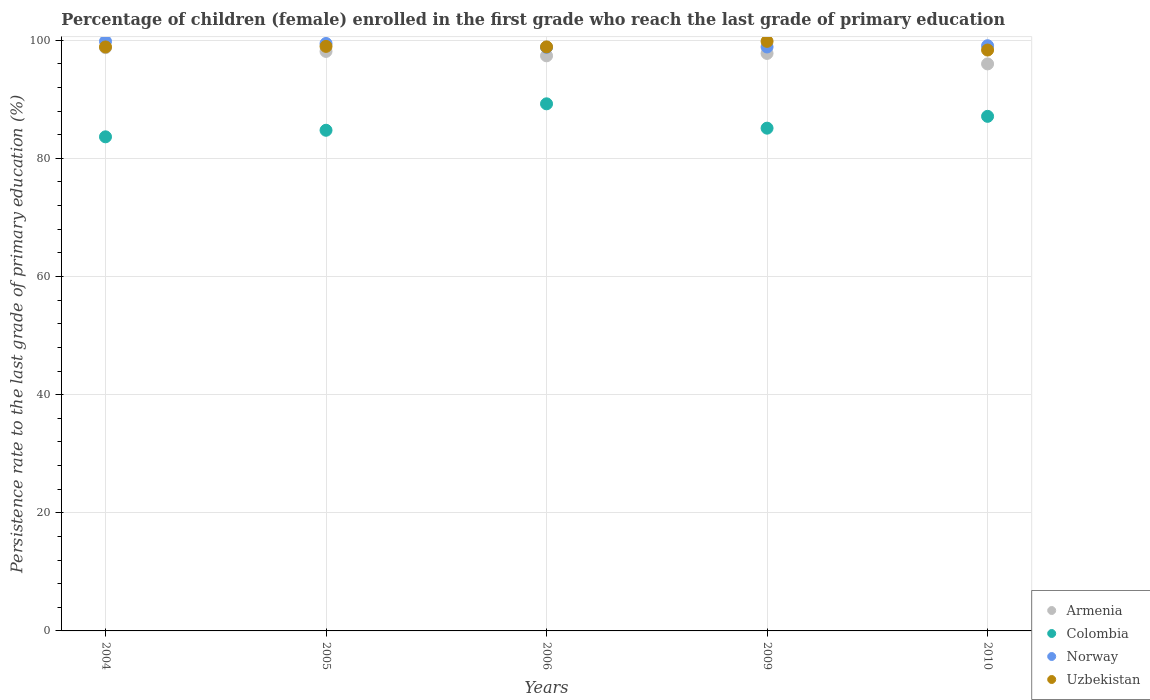How many different coloured dotlines are there?
Give a very brief answer. 4. What is the persistence rate of children in Uzbekistan in 2004?
Provide a short and direct response. 98.86. Across all years, what is the maximum persistence rate of children in Uzbekistan?
Give a very brief answer. 99.81. Across all years, what is the minimum persistence rate of children in Colombia?
Your response must be concise. 83.64. What is the total persistence rate of children in Uzbekistan in the graph?
Make the answer very short. 494.83. What is the difference between the persistence rate of children in Armenia in 2004 and that in 2009?
Give a very brief answer. 0.97. What is the difference between the persistence rate of children in Uzbekistan in 2009 and the persistence rate of children in Colombia in 2010?
Give a very brief answer. 12.69. What is the average persistence rate of children in Norway per year?
Make the answer very short. 99.19. In the year 2004, what is the difference between the persistence rate of children in Armenia and persistence rate of children in Colombia?
Give a very brief answer. 15.09. What is the ratio of the persistence rate of children in Colombia in 2005 to that in 2009?
Your response must be concise. 1. Is the persistence rate of children in Colombia in 2004 less than that in 2005?
Give a very brief answer. Yes. Is the difference between the persistence rate of children in Armenia in 2004 and 2010 greater than the difference between the persistence rate of children in Colombia in 2004 and 2010?
Keep it short and to the point. Yes. What is the difference between the highest and the second highest persistence rate of children in Norway?
Your answer should be compact. 0.36. What is the difference between the highest and the lowest persistence rate of children in Armenia?
Offer a very short reply. 2.75. Does the persistence rate of children in Uzbekistan monotonically increase over the years?
Offer a terse response. No. Is the persistence rate of children in Norway strictly less than the persistence rate of children in Armenia over the years?
Provide a succinct answer. No. Does the graph contain grids?
Keep it short and to the point. Yes. Where does the legend appear in the graph?
Your answer should be compact. Bottom right. How many legend labels are there?
Offer a terse response. 4. What is the title of the graph?
Provide a short and direct response. Percentage of children (female) enrolled in the first grade who reach the last grade of primary education. What is the label or title of the X-axis?
Ensure brevity in your answer.  Years. What is the label or title of the Y-axis?
Offer a terse response. Persistence rate to the last grade of primary education (%). What is the Persistence rate to the last grade of primary education (%) in Armenia in 2004?
Keep it short and to the point. 98.74. What is the Persistence rate to the last grade of primary education (%) in Colombia in 2004?
Provide a short and direct response. 83.64. What is the Persistence rate to the last grade of primary education (%) of Norway in 2004?
Offer a very short reply. 99.8. What is the Persistence rate to the last grade of primary education (%) of Uzbekistan in 2004?
Offer a very short reply. 98.86. What is the Persistence rate to the last grade of primary education (%) of Armenia in 2005?
Keep it short and to the point. 98.1. What is the Persistence rate to the last grade of primary education (%) of Colombia in 2005?
Provide a succinct answer. 84.75. What is the Persistence rate to the last grade of primary education (%) of Norway in 2005?
Make the answer very short. 99.45. What is the Persistence rate to the last grade of primary education (%) in Uzbekistan in 2005?
Provide a short and direct response. 98.95. What is the Persistence rate to the last grade of primary education (%) in Armenia in 2006?
Give a very brief answer. 97.36. What is the Persistence rate to the last grade of primary education (%) in Colombia in 2006?
Ensure brevity in your answer.  89.23. What is the Persistence rate to the last grade of primary education (%) in Norway in 2006?
Provide a short and direct response. 98.8. What is the Persistence rate to the last grade of primary education (%) in Uzbekistan in 2006?
Offer a terse response. 98.87. What is the Persistence rate to the last grade of primary education (%) in Armenia in 2009?
Provide a short and direct response. 97.76. What is the Persistence rate to the last grade of primary education (%) of Colombia in 2009?
Give a very brief answer. 85.11. What is the Persistence rate to the last grade of primary education (%) in Norway in 2009?
Provide a succinct answer. 98.85. What is the Persistence rate to the last grade of primary education (%) in Uzbekistan in 2009?
Ensure brevity in your answer.  99.81. What is the Persistence rate to the last grade of primary education (%) in Armenia in 2010?
Provide a short and direct response. 95.99. What is the Persistence rate to the last grade of primary education (%) in Colombia in 2010?
Provide a short and direct response. 87.11. What is the Persistence rate to the last grade of primary education (%) of Norway in 2010?
Offer a terse response. 99.07. What is the Persistence rate to the last grade of primary education (%) of Uzbekistan in 2010?
Your answer should be very brief. 98.33. Across all years, what is the maximum Persistence rate to the last grade of primary education (%) of Armenia?
Your answer should be compact. 98.74. Across all years, what is the maximum Persistence rate to the last grade of primary education (%) in Colombia?
Make the answer very short. 89.23. Across all years, what is the maximum Persistence rate to the last grade of primary education (%) of Norway?
Offer a very short reply. 99.8. Across all years, what is the maximum Persistence rate to the last grade of primary education (%) in Uzbekistan?
Offer a very short reply. 99.81. Across all years, what is the minimum Persistence rate to the last grade of primary education (%) of Armenia?
Ensure brevity in your answer.  95.99. Across all years, what is the minimum Persistence rate to the last grade of primary education (%) of Colombia?
Give a very brief answer. 83.64. Across all years, what is the minimum Persistence rate to the last grade of primary education (%) in Norway?
Provide a short and direct response. 98.8. Across all years, what is the minimum Persistence rate to the last grade of primary education (%) in Uzbekistan?
Provide a short and direct response. 98.33. What is the total Persistence rate to the last grade of primary education (%) in Armenia in the graph?
Make the answer very short. 487.95. What is the total Persistence rate to the last grade of primary education (%) of Colombia in the graph?
Give a very brief answer. 429.85. What is the total Persistence rate to the last grade of primary education (%) of Norway in the graph?
Provide a short and direct response. 495.97. What is the total Persistence rate to the last grade of primary education (%) in Uzbekistan in the graph?
Offer a terse response. 494.83. What is the difference between the Persistence rate to the last grade of primary education (%) in Armenia in 2004 and that in 2005?
Provide a succinct answer. 0.63. What is the difference between the Persistence rate to the last grade of primary education (%) in Colombia in 2004 and that in 2005?
Provide a succinct answer. -1.11. What is the difference between the Persistence rate to the last grade of primary education (%) in Norway in 2004 and that in 2005?
Offer a very short reply. 0.36. What is the difference between the Persistence rate to the last grade of primary education (%) of Uzbekistan in 2004 and that in 2005?
Your response must be concise. -0.09. What is the difference between the Persistence rate to the last grade of primary education (%) of Armenia in 2004 and that in 2006?
Make the answer very short. 1.38. What is the difference between the Persistence rate to the last grade of primary education (%) of Colombia in 2004 and that in 2006?
Make the answer very short. -5.59. What is the difference between the Persistence rate to the last grade of primary education (%) in Norway in 2004 and that in 2006?
Provide a short and direct response. 1.01. What is the difference between the Persistence rate to the last grade of primary education (%) in Uzbekistan in 2004 and that in 2006?
Keep it short and to the point. -0.01. What is the difference between the Persistence rate to the last grade of primary education (%) in Armenia in 2004 and that in 2009?
Your response must be concise. 0.97. What is the difference between the Persistence rate to the last grade of primary education (%) in Colombia in 2004 and that in 2009?
Offer a very short reply. -1.47. What is the difference between the Persistence rate to the last grade of primary education (%) of Norway in 2004 and that in 2009?
Your answer should be compact. 0.95. What is the difference between the Persistence rate to the last grade of primary education (%) in Uzbekistan in 2004 and that in 2009?
Make the answer very short. -0.95. What is the difference between the Persistence rate to the last grade of primary education (%) in Armenia in 2004 and that in 2010?
Keep it short and to the point. 2.75. What is the difference between the Persistence rate to the last grade of primary education (%) of Colombia in 2004 and that in 2010?
Make the answer very short. -3.47. What is the difference between the Persistence rate to the last grade of primary education (%) in Norway in 2004 and that in 2010?
Offer a terse response. 0.74. What is the difference between the Persistence rate to the last grade of primary education (%) of Uzbekistan in 2004 and that in 2010?
Your response must be concise. 0.53. What is the difference between the Persistence rate to the last grade of primary education (%) of Armenia in 2005 and that in 2006?
Your answer should be compact. 0.75. What is the difference between the Persistence rate to the last grade of primary education (%) of Colombia in 2005 and that in 2006?
Give a very brief answer. -4.48. What is the difference between the Persistence rate to the last grade of primary education (%) in Norway in 2005 and that in 2006?
Offer a terse response. 0.65. What is the difference between the Persistence rate to the last grade of primary education (%) in Uzbekistan in 2005 and that in 2006?
Provide a succinct answer. 0.08. What is the difference between the Persistence rate to the last grade of primary education (%) in Armenia in 2005 and that in 2009?
Ensure brevity in your answer.  0.34. What is the difference between the Persistence rate to the last grade of primary education (%) of Colombia in 2005 and that in 2009?
Your response must be concise. -0.36. What is the difference between the Persistence rate to the last grade of primary education (%) of Norway in 2005 and that in 2009?
Offer a terse response. 0.59. What is the difference between the Persistence rate to the last grade of primary education (%) of Uzbekistan in 2005 and that in 2009?
Offer a very short reply. -0.85. What is the difference between the Persistence rate to the last grade of primary education (%) of Armenia in 2005 and that in 2010?
Your answer should be compact. 2.12. What is the difference between the Persistence rate to the last grade of primary education (%) in Colombia in 2005 and that in 2010?
Your answer should be compact. -2.36. What is the difference between the Persistence rate to the last grade of primary education (%) in Norway in 2005 and that in 2010?
Offer a very short reply. 0.38. What is the difference between the Persistence rate to the last grade of primary education (%) in Uzbekistan in 2005 and that in 2010?
Offer a very short reply. 0.62. What is the difference between the Persistence rate to the last grade of primary education (%) in Armenia in 2006 and that in 2009?
Your response must be concise. -0.41. What is the difference between the Persistence rate to the last grade of primary education (%) of Colombia in 2006 and that in 2009?
Make the answer very short. 4.12. What is the difference between the Persistence rate to the last grade of primary education (%) in Norway in 2006 and that in 2009?
Provide a succinct answer. -0.06. What is the difference between the Persistence rate to the last grade of primary education (%) of Uzbekistan in 2006 and that in 2009?
Give a very brief answer. -0.94. What is the difference between the Persistence rate to the last grade of primary education (%) of Armenia in 2006 and that in 2010?
Your answer should be compact. 1.37. What is the difference between the Persistence rate to the last grade of primary education (%) in Colombia in 2006 and that in 2010?
Offer a terse response. 2.12. What is the difference between the Persistence rate to the last grade of primary education (%) of Norway in 2006 and that in 2010?
Ensure brevity in your answer.  -0.27. What is the difference between the Persistence rate to the last grade of primary education (%) in Uzbekistan in 2006 and that in 2010?
Provide a succinct answer. 0.54. What is the difference between the Persistence rate to the last grade of primary education (%) of Armenia in 2009 and that in 2010?
Your answer should be very brief. 1.77. What is the difference between the Persistence rate to the last grade of primary education (%) of Colombia in 2009 and that in 2010?
Your answer should be very brief. -2. What is the difference between the Persistence rate to the last grade of primary education (%) in Norway in 2009 and that in 2010?
Provide a succinct answer. -0.21. What is the difference between the Persistence rate to the last grade of primary education (%) of Uzbekistan in 2009 and that in 2010?
Keep it short and to the point. 1.47. What is the difference between the Persistence rate to the last grade of primary education (%) of Armenia in 2004 and the Persistence rate to the last grade of primary education (%) of Colombia in 2005?
Offer a very short reply. 13.98. What is the difference between the Persistence rate to the last grade of primary education (%) of Armenia in 2004 and the Persistence rate to the last grade of primary education (%) of Norway in 2005?
Your answer should be very brief. -0.71. What is the difference between the Persistence rate to the last grade of primary education (%) of Armenia in 2004 and the Persistence rate to the last grade of primary education (%) of Uzbekistan in 2005?
Offer a very short reply. -0.22. What is the difference between the Persistence rate to the last grade of primary education (%) in Colombia in 2004 and the Persistence rate to the last grade of primary education (%) in Norway in 2005?
Give a very brief answer. -15.8. What is the difference between the Persistence rate to the last grade of primary education (%) of Colombia in 2004 and the Persistence rate to the last grade of primary education (%) of Uzbekistan in 2005?
Provide a succinct answer. -15.31. What is the difference between the Persistence rate to the last grade of primary education (%) in Norway in 2004 and the Persistence rate to the last grade of primary education (%) in Uzbekistan in 2005?
Your response must be concise. 0.85. What is the difference between the Persistence rate to the last grade of primary education (%) in Armenia in 2004 and the Persistence rate to the last grade of primary education (%) in Colombia in 2006?
Provide a short and direct response. 9.51. What is the difference between the Persistence rate to the last grade of primary education (%) in Armenia in 2004 and the Persistence rate to the last grade of primary education (%) in Norway in 2006?
Your answer should be compact. -0.06. What is the difference between the Persistence rate to the last grade of primary education (%) of Armenia in 2004 and the Persistence rate to the last grade of primary education (%) of Uzbekistan in 2006?
Your response must be concise. -0.13. What is the difference between the Persistence rate to the last grade of primary education (%) in Colombia in 2004 and the Persistence rate to the last grade of primary education (%) in Norway in 2006?
Provide a short and direct response. -15.15. What is the difference between the Persistence rate to the last grade of primary education (%) of Colombia in 2004 and the Persistence rate to the last grade of primary education (%) of Uzbekistan in 2006?
Offer a very short reply. -15.23. What is the difference between the Persistence rate to the last grade of primary education (%) in Norway in 2004 and the Persistence rate to the last grade of primary education (%) in Uzbekistan in 2006?
Your answer should be compact. 0.93. What is the difference between the Persistence rate to the last grade of primary education (%) in Armenia in 2004 and the Persistence rate to the last grade of primary education (%) in Colombia in 2009?
Provide a short and direct response. 13.63. What is the difference between the Persistence rate to the last grade of primary education (%) in Armenia in 2004 and the Persistence rate to the last grade of primary education (%) in Norway in 2009?
Keep it short and to the point. -0.12. What is the difference between the Persistence rate to the last grade of primary education (%) in Armenia in 2004 and the Persistence rate to the last grade of primary education (%) in Uzbekistan in 2009?
Offer a terse response. -1.07. What is the difference between the Persistence rate to the last grade of primary education (%) in Colombia in 2004 and the Persistence rate to the last grade of primary education (%) in Norway in 2009?
Ensure brevity in your answer.  -15.21. What is the difference between the Persistence rate to the last grade of primary education (%) in Colombia in 2004 and the Persistence rate to the last grade of primary education (%) in Uzbekistan in 2009?
Ensure brevity in your answer.  -16.16. What is the difference between the Persistence rate to the last grade of primary education (%) of Norway in 2004 and the Persistence rate to the last grade of primary education (%) of Uzbekistan in 2009?
Offer a very short reply. -0. What is the difference between the Persistence rate to the last grade of primary education (%) in Armenia in 2004 and the Persistence rate to the last grade of primary education (%) in Colombia in 2010?
Your response must be concise. 11.62. What is the difference between the Persistence rate to the last grade of primary education (%) of Armenia in 2004 and the Persistence rate to the last grade of primary education (%) of Norway in 2010?
Offer a very short reply. -0.33. What is the difference between the Persistence rate to the last grade of primary education (%) in Armenia in 2004 and the Persistence rate to the last grade of primary education (%) in Uzbekistan in 2010?
Give a very brief answer. 0.4. What is the difference between the Persistence rate to the last grade of primary education (%) in Colombia in 2004 and the Persistence rate to the last grade of primary education (%) in Norway in 2010?
Your response must be concise. -15.42. What is the difference between the Persistence rate to the last grade of primary education (%) in Colombia in 2004 and the Persistence rate to the last grade of primary education (%) in Uzbekistan in 2010?
Offer a very short reply. -14.69. What is the difference between the Persistence rate to the last grade of primary education (%) of Norway in 2004 and the Persistence rate to the last grade of primary education (%) of Uzbekistan in 2010?
Make the answer very short. 1.47. What is the difference between the Persistence rate to the last grade of primary education (%) of Armenia in 2005 and the Persistence rate to the last grade of primary education (%) of Colombia in 2006?
Give a very brief answer. 8.87. What is the difference between the Persistence rate to the last grade of primary education (%) of Armenia in 2005 and the Persistence rate to the last grade of primary education (%) of Norway in 2006?
Ensure brevity in your answer.  -0.69. What is the difference between the Persistence rate to the last grade of primary education (%) in Armenia in 2005 and the Persistence rate to the last grade of primary education (%) in Uzbekistan in 2006?
Your answer should be very brief. -0.77. What is the difference between the Persistence rate to the last grade of primary education (%) in Colombia in 2005 and the Persistence rate to the last grade of primary education (%) in Norway in 2006?
Make the answer very short. -14.04. What is the difference between the Persistence rate to the last grade of primary education (%) of Colombia in 2005 and the Persistence rate to the last grade of primary education (%) of Uzbekistan in 2006?
Give a very brief answer. -14.12. What is the difference between the Persistence rate to the last grade of primary education (%) in Norway in 2005 and the Persistence rate to the last grade of primary education (%) in Uzbekistan in 2006?
Your answer should be compact. 0.58. What is the difference between the Persistence rate to the last grade of primary education (%) in Armenia in 2005 and the Persistence rate to the last grade of primary education (%) in Colombia in 2009?
Give a very brief answer. 12.99. What is the difference between the Persistence rate to the last grade of primary education (%) in Armenia in 2005 and the Persistence rate to the last grade of primary education (%) in Norway in 2009?
Your answer should be very brief. -0.75. What is the difference between the Persistence rate to the last grade of primary education (%) in Armenia in 2005 and the Persistence rate to the last grade of primary education (%) in Uzbekistan in 2009?
Your answer should be very brief. -1.7. What is the difference between the Persistence rate to the last grade of primary education (%) of Colombia in 2005 and the Persistence rate to the last grade of primary education (%) of Norway in 2009?
Ensure brevity in your answer.  -14.1. What is the difference between the Persistence rate to the last grade of primary education (%) of Colombia in 2005 and the Persistence rate to the last grade of primary education (%) of Uzbekistan in 2009?
Offer a very short reply. -15.05. What is the difference between the Persistence rate to the last grade of primary education (%) of Norway in 2005 and the Persistence rate to the last grade of primary education (%) of Uzbekistan in 2009?
Ensure brevity in your answer.  -0.36. What is the difference between the Persistence rate to the last grade of primary education (%) of Armenia in 2005 and the Persistence rate to the last grade of primary education (%) of Colombia in 2010?
Provide a succinct answer. 10.99. What is the difference between the Persistence rate to the last grade of primary education (%) of Armenia in 2005 and the Persistence rate to the last grade of primary education (%) of Norway in 2010?
Keep it short and to the point. -0.96. What is the difference between the Persistence rate to the last grade of primary education (%) in Armenia in 2005 and the Persistence rate to the last grade of primary education (%) in Uzbekistan in 2010?
Your response must be concise. -0.23. What is the difference between the Persistence rate to the last grade of primary education (%) of Colombia in 2005 and the Persistence rate to the last grade of primary education (%) of Norway in 2010?
Your answer should be compact. -14.31. What is the difference between the Persistence rate to the last grade of primary education (%) in Colombia in 2005 and the Persistence rate to the last grade of primary education (%) in Uzbekistan in 2010?
Offer a very short reply. -13.58. What is the difference between the Persistence rate to the last grade of primary education (%) in Norway in 2005 and the Persistence rate to the last grade of primary education (%) in Uzbekistan in 2010?
Ensure brevity in your answer.  1.11. What is the difference between the Persistence rate to the last grade of primary education (%) in Armenia in 2006 and the Persistence rate to the last grade of primary education (%) in Colombia in 2009?
Your answer should be compact. 12.25. What is the difference between the Persistence rate to the last grade of primary education (%) of Armenia in 2006 and the Persistence rate to the last grade of primary education (%) of Norway in 2009?
Your answer should be compact. -1.5. What is the difference between the Persistence rate to the last grade of primary education (%) of Armenia in 2006 and the Persistence rate to the last grade of primary education (%) of Uzbekistan in 2009?
Provide a short and direct response. -2.45. What is the difference between the Persistence rate to the last grade of primary education (%) in Colombia in 2006 and the Persistence rate to the last grade of primary education (%) in Norway in 2009?
Offer a terse response. -9.62. What is the difference between the Persistence rate to the last grade of primary education (%) of Colombia in 2006 and the Persistence rate to the last grade of primary education (%) of Uzbekistan in 2009?
Provide a succinct answer. -10.58. What is the difference between the Persistence rate to the last grade of primary education (%) of Norway in 2006 and the Persistence rate to the last grade of primary education (%) of Uzbekistan in 2009?
Your answer should be compact. -1.01. What is the difference between the Persistence rate to the last grade of primary education (%) in Armenia in 2006 and the Persistence rate to the last grade of primary education (%) in Colombia in 2010?
Your answer should be compact. 10.24. What is the difference between the Persistence rate to the last grade of primary education (%) of Armenia in 2006 and the Persistence rate to the last grade of primary education (%) of Norway in 2010?
Your answer should be compact. -1.71. What is the difference between the Persistence rate to the last grade of primary education (%) of Armenia in 2006 and the Persistence rate to the last grade of primary education (%) of Uzbekistan in 2010?
Offer a very short reply. -0.98. What is the difference between the Persistence rate to the last grade of primary education (%) of Colombia in 2006 and the Persistence rate to the last grade of primary education (%) of Norway in 2010?
Provide a short and direct response. -9.84. What is the difference between the Persistence rate to the last grade of primary education (%) in Colombia in 2006 and the Persistence rate to the last grade of primary education (%) in Uzbekistan in 2010?
Your answer should be compact. -9.1. What is the difference between the Persistence rate to the last grade of primary education (%) in Norway in 2006 and the Persistence rate to the last grade of primary education (%) in Uzbekistan in 2010?
Offer a very short reply. 0.46. What is the difference between the Persistence rate to the last grade of primary education (%) of Armenia in 2009 and the Persistence rate to the last grade of primary education (%) of Colombia in 2010?
Give a very brief answer. 10.65. What is the difference between the Persistence rate to the last grade of primary education (%) in Armenia in 2009 and the Persistence rate to the last grade of primary education (%) in Norway in 2010?
Provide a short and direct response. -1.3. What is the difference between the Persistence rate to the last grade of primary education (%) of Armenia in 2009 and the Persistence rate to the last grade of primary education (%) of Uzbekistan in 2010?
Your answer should be very brief. -0.57. What is the difference between the Persistence rate to the last grade of primary education (%) of Colombia in 2009 and the Persistence rate to the last grade of primary education (%) of Norway in 2010?
Make the answer very short. -13.96. What is the difference between the Persistence rate to the last grade of primary education (%) of Colombia in 2009 and the Persistence rate to the last grade of primary education (%) of Uzbekistan in 2010?
Offer a very short reply. -13.22. What is the difference between the Persistence rate to the last grade of primary education (%) of Norway in 2009 and the Persistence rate to the last grade of primary education (%) of Uzbekistan in 2010?
Ensure brevity in your answer.  0.52. What is the average Persistence rate to the last grade of primary education (%) in Armenia per year?
Your response must be concise. 97.59. What is the average Persistence rate to the last grade of primary education (%) of Colombia per year?
Keep it short and to the point. 85.97. What is the average Persistence rate to the last grade of primary education (%) in Norway per year?
Offer a very short reply. 99.19. What is the average Persistence rate to the last grade of primary education (%) of Uzbekistan per year?
Make the answer very short. 98.97. In the year 2004, what is the difference between the Persistence rate to the last grade of primary education (%) in Armenia and Persistence rate to the last grade of primary education (%) in Colombia?
Your answer should be very brief. 15.09. In the year 2004, what is the difference between the Persistence rate to the last grade of primary education (%) of Armenia and Persistence rate to the last grade of primary education (%) of Norway?
Offer a very short reply. -1.07. In the year 2004, what is the difference between the Persistence rate to the last grade of primary education (%) of Armenia and Persistence rate to the last grade of primary education (%) of Uzbekistan?
Give a very brief answer. -0.12. In the year 2004, what is the difference between the Persistence rate to the last grade of primary education (%) of Colombia and Persistence rate to the last grade of primary education (%) of Norway?
Make the answer very short. -16.16. In the year 2004, what is the difference between the Persistence rate to the last grade of primary education (%) in Colombia and Persistence rate to the last grade of primary education (%) in Uzbekistan?
Offer a terse response. -15.22. In the year 2004, what is the difference between the Persistence rate to the last grade of primary education (%) in Norway and Persistence rate to the last grade of primary education (%) in Uzbekistan?
Your answer should be compact. 0.94. In the year 2005, what is the difference between the Persistence rate to the last grade of primary education (%) in Armenia and Persistence rate to the last grade of primary education (%) in Colombia?
Offer a terse response. 13.35. In the year 2005, what is the difference between the Persistence rate to the last grade of primary education (%) in Armenia and Persistence rate to the last grade of primary education (%) in Norway?
Provide a short and direct response. -1.34. In the year 2005, what is the difference between the Persistence rate to the last grade of primary education (%) of Armenia and Persistence rate to the last grade of primary education (%) of Uzbekistan?
Provide a short and direct response. -0.85. In the year 2005, what is the difference between the Persistence rate to the last grade of primary education (%) in Colombia and Persistence rate to the last grade of primary education (%) in Norway?
Offer a terse response. -14.69. In the year 2005, what is the difference between the Persistence rate to the last grade of primary education (%) of Colombia and Persistence rate to the last grade of primary education (%) of Uzbekistan?
Provide a succinct answer. -14.2. In the year 2005, what is the difference between the Persistence rate to the last grade of primary education (%) in Norway and Persistence rate to the last grade of primary education (%) in Uzbekistan?
Your answer should be compact. 0.49. In the year 2006, what is the difference between the Persistence rate to the last grade of primary education (%) of Armenia and Persistence rate to the last grade of primary education (%) of Colombia?
Your response must be concise. 8.13. In the year 2006, what is the difference between the Persistence rate to the last grade of primary education (%) in Armenia and Persistence rate to the last grade of primary education (%) in Norway?
Your response must be concise. -1.44. In the year 2006, what is the difference between the Persistence rate to the last grade of primary education (%) in Armenia and Persistence rate to the last grade of primary education (%) in Uzbekistan?
Make the answer very short. -1.51. In the year 2006, what is the difference between the Persistence rate to the last grade of primary education (%) of Colombia and Persistence rate to the last grade of primary education (%) of Norway?
Keep it short and to the point. -9.56. In the year 2006, what is the difference between the Persistence rate to the last grade of primary education (%) of Colombia and Persistence rate to the last grade of primary education (%) of Uzbekistan?
Give a very brief answer. -9.64. In the year 2006, what is the difference between the Persistence rate to the last grade of primary education (%) in Norway and Persistence rate to the last grade of primary education (%) in Uzbekistan?
Ensure brevity in your answer.  -0.08. In the year 2009, what is the difference between the Persistence rate to the last grade of primary education (%) of Armenia and Persistence rate to the last grade of primary education (%) of Colombia?
Ensure brevity in your answer.  12.65. In the year 2009, what is the difference between the Persistence rate to the last grade of primary education (%) of Armenia and Persistence rate to the last grade of primary education (%) of Norway?
Make the answer very short. -1.09. In the year 2009, what is the difference between the Persistence rate to the last grade of primary education (%) of Armenia and Persistence rate to the last grade of primary education (%) of Uzbekistan?
Your response must be concise. -2.04. In the year 2009, what is the difference between the Persistence rate to the last grade of primary education (%) in Colombia and Persistence rate to the last grade of primary education (%) in Norway?
Keep it short and to the point. -13.74. In the year 2009, what is the difference between the Persistence rate to the last grade of primary education (%) in Colombia and Persistence rate to the last grade of primary education (%) in Uzbekistan?
Your answer should be very brief. -14.7. In the year 2009, what is the difference between the Persistence rate to the last grade of primary education (%) of Norway and Persistence rate to the last grade of primary education (%) of Uzbekistan?
Offer a very short reply. -0.95. In the year 2010, what is the difference between the Persistence rate to the last grade of primary education (%) of Armenia and Persistence rate to the last grade of primary education (%) of Colombia?
Provide a short and direct response. 8.88. In the year 2010, what is the difference between the Persistence rate to the last grade of primary education (%) in Armenia and Persistence rate to the last grade of primary education (%) in Norway?
Offer a very short reply. -3.08. In the year 2010, what is the difference between the Persistence rate to the last grade of primary education (%) of Armenia and Persistence rate to the last grade of primary education (%) of Uzbekistan?
Make the answer very short. -2.35. In the year 2010, what is the difference between the Persistence rate to the last grade of primary education (%) of Colombia and Persistence rate to the last grade of primary education (%) of Norway?
Provide a short and direct response. -11.95. In the year 2010, what is the difference between the Persistence rate to the last grade of primary education (%) in Colombia and Persistence rate to the last grade of primary education (%) in Uzbekistan?
Your response must be concise. -11.22. In the year 2010, what is the difference between the Persistence rate to the last grade of primary education (%) of Norway and Persistence rate to the last grade of primary education (%) of Uzbekistan?
Make the answer very short. 0.73. What is the ratio of the Persistence rate to the last grade of primary education (%) of Armenia in 2004 to that in 2005?
Your answer should be compact. 1.01. What is the ratio of the Persistence rate to the last grade of primary education (%) of Colombia in 2004 to that in 2005?
Give a very brief answer. 0.99. What is the ratio of the Persistence rate to the last grade of primary education (%) of Norway in 2004 to that in 2005?
Your answer should be compact. 1. What is the ratio of the Persistence rate to the last grade of primary education (%) in Armenia in 2004 to that in 2006?
Ensure brevity in your answer.  1.01. What is the ratio of the Persistence rate to the last grade of primary education (%) in Colombia in 2004 to that in 2006?
Give a very brief answer. 0.94. What is the ratio of the Persistence rate to the last grade of primary education (%) in Norway in 2004 to that in 2006?
Provide a short and direct response. 1.01. What is the ratio of the Persistence rate to the last grade of primary education (%) of Armenia in 2004 to that in 2009?
Offer a very short reply. 1.01. What is the ratio of the Persistence rate to the last grade of primary education (%) in Colombia in 2004 to that in 2009?
Keep it short and to the point. 0.98. What is the ratio of the Persistence rate to the last grade of primary education (%) in Norway in 2004 to that in 2009?
Keep it short and to the point. 1.01. What is the ratio of the Persistence rate to the last grade of primary education (%) of Armenia in 2004 to that in 2010?
Make the answer very short. 1.03. What is the ratio of the Persistence rate to the last grade of primary education (%) in Colombia in 2004 to that in 2010?
Provide a succinct answer. 0.96. What is the ratio of the Persistence rate to the last grade of primary education (%) in Norway in 2004 to that in 2010?
Ensure brevity in your answer.  1.01. What is the ratio of the Persistence rate to the last grade of primary education (%) in Uzbekistan in 2004 to that in 2010?
Provide a short and direct response. 1.01. What is the ratio of the Persistence rate to the last grade of primary education (%) of Armenia in 2005 to that in 2006?
Keep it short and to the point. 1.01. What is the ratio of the Persistence rate to the last grade of primary education (%) in Colombia in 2005 to that in 2006?
Your answer should be compact. 0.95. What is the ratio of the Persistence rate to the last grade of primary education (%) in Norway in 2005 to that in 2006?
Keep it short and to the point. 1.01. What is the ratio of the Persistence rate to the last grade of primary education (%) in Colombia in 2005 to that in 2009?
Your response must be concise. 1. What is the ratio of the Persistence rate to the last grade of primary education (%) of Norway in 2005 to that in 2009?
Give a very brief answer. 1.01. What is the ratio of the Persistence rate to the last grade of primary education (%) of Armenia in 2005 to that in 2010?
Offer a terse response. 1.02. What is the ratio of the Persistence rate to the last grade of primary education (%) of Colombia in 2005 to that in 2010?
Provide a succinct answer. 0.97. What is the ratio of the Persistence rate to the last grade of primary education (%) in Norway in 2005 to that in 2010?
Offer a terse response. 1. What is the ratio of the Persistence rate to the last grade of primary education (%) in Uzbekistan in 2005 to that in 2010?
Ensure brevity in your answer.  1.01. What is the ratio of the Persistence rate to the last grade of primary education (%) in Armenia in 2006 to that in 2009?
Your answer should be compact. 1. What is the ratio of the Persistence rate to the last grade of primary education (%) of Colombia in 2006 to that in 2009?
Your answer should be compact. 1.05. What is the ratio of the Persistence rate to the last grade of primary education (%) of Norway in 2006 to that in 2009?
Ensure brevity in your answer.  1. What is the ratio of the Persistence rate to the last grade of primary education (%) in Uzbekistan in 2006 to that in 2009?
Offer a terse response. 0.99. What is the ratio of the Persistence rate to the last grade of primary education (%) in Armenia in 2006 to that in 2010?
Your response must be concise. 1.01. What is the ratio of the Persistence rate to the last grade of primary education (%) in Colombia in 2006 to that in 2010?
Your answer should be very brief. 1.02. What is the ratio of the Persistence rate to the last grade of primary education (%) of Norway in 2006 to that in 2010?
Provide a succinct answer. 1. What is the ratio of the Persistence rate to the last grade of primary education (%) of Armenia in 2009 to that in 2010?
Your response must be concise. 1.02. What is the ratio of the Persistence rate to the last grade of primary education (%) in Uzbekistan in 2009 to that in 2010?
Provide a succinct answer. 1.01. What is the difference between the highest and the second highest Persistence rate to the last grade of primary education (%) of Armenia?
Your answer should be very brief. 0.63. What is the difference between the highest and the second highest Persistence rate to the last grade of primary education (%) in Colombia?
Your answer should be compact. 2.12. What is the difference between the highest and the second highest Persistence rate to the last grade of primary education (%) in Norway?
Provide a short and direct response. 0.36. What is the difference between the highest and the second highest Persistence rate to the last grade of primary education (%) of Uzbekistan?
Offer a very short reply. 0.85. What is the difference between the highest and the lowest Persistence rate to the last grade of primary education (%) in Armenia?
Ensure brevity in your answer.  2.75. What is the difference between the highest and the lowest Persistence rate to the last grade of primary education (%) of Colombia?
Your response must be concise. 5.59. What is the difference between the highest and the lowest Persistence rate to the last grade of primary education (%) in Norway?
Your response must be concise. 1.01. What is the difference between the highest and the lowest Persistence rate to the last grade of primary education (%) of Uzbekistan?
Your answer should be very brief. 1.47. 